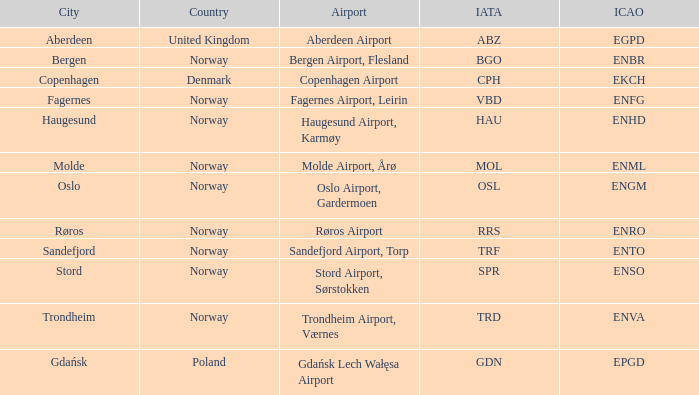What Airport's ICAO is ENTO? Sandefjord Airport, Torp. 